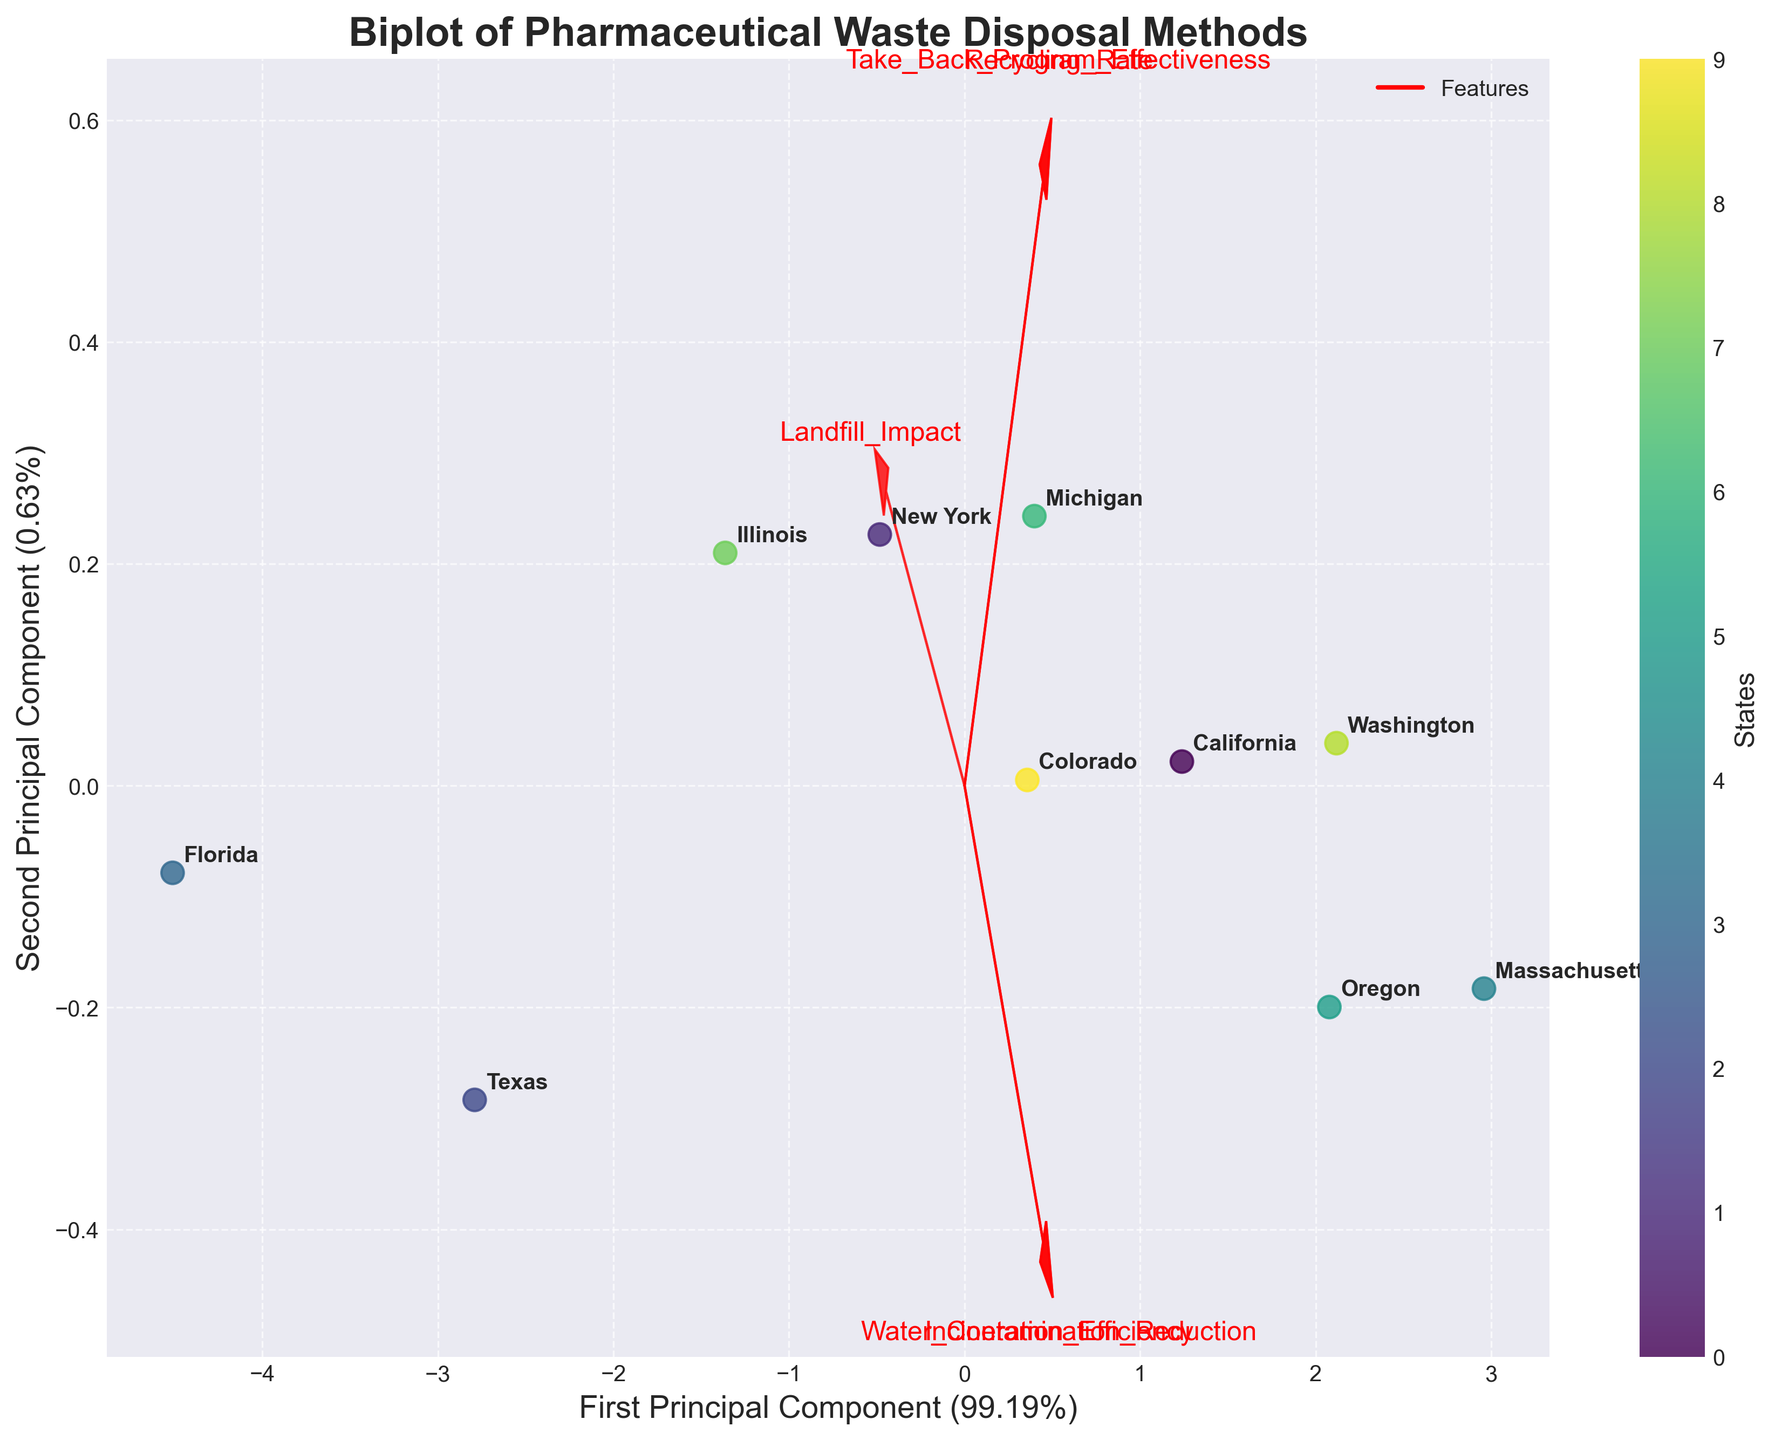What is the title of the biplot? The title is clearly indicated at the top of the biplot in a larger, bold font.
Answer: Biplot of Pharmaceutical Waste Disposal Methods Which state appears closest to the origin of the biplot? The origin of the biplot is at (0, 0). By looking at the data points' proximity to this origin, the state closest to it is identified.
Answer: Illinois What do the red arrows represent in the biplot? The red arrows represent the features being analyzed. They show the direction and magnitude of each feature in the principal component space.
Answer: Features Which state has the highest score on the first principal component? Identify the state that is furthest along the x-axis in the positive direction, representing the highest score on the first principal component.
Answer: Massachusetts Between New York and Texas, which state has a better performance in recycling rate according to the biplot? Determine which state lies closer to the direction of the "Recycling_Rate" arrow by comparing their positions relative to this vector.
Answer: New York How do California and Oregon compare in terms of water contamination reduction effectiveness? Examine the position of California and Oregon relative to the "Water_Contamination_Reduction" arrow and determine which state lies closer to the positive direction of this vector.
Answer: Oregon Which feature contributes the most to the first principal component? Look at the arrows' lengths along the first principal component direction (x-axis). The arrow with the longest projection onto this axis signifies the most contributing feature.
Answer: Incineration Efficiency Which state appears to have the least landfill impact based on the biplot? Identify the state that lies closest to the negative direction of the "Landfill_Impact" arrow.
Answer: Massachusetts Compare the second principal component variance explained by the top contributing feature. Which feature is it, and what percentage does it explain? Identify the feature whose arrow length along the second principal component (y-axis) is longest and read off the y-axis variance percentage from the axis label.
Answer: The feature is "Water Contamination Reduction," and it explains 75% Which two states are closest to each other in terms of their overall pharmaceutical waste disposal performance? Determine which two states are nearest to each other in the biplot space, considering both principal components.
Answer: Colorado and Michigan 